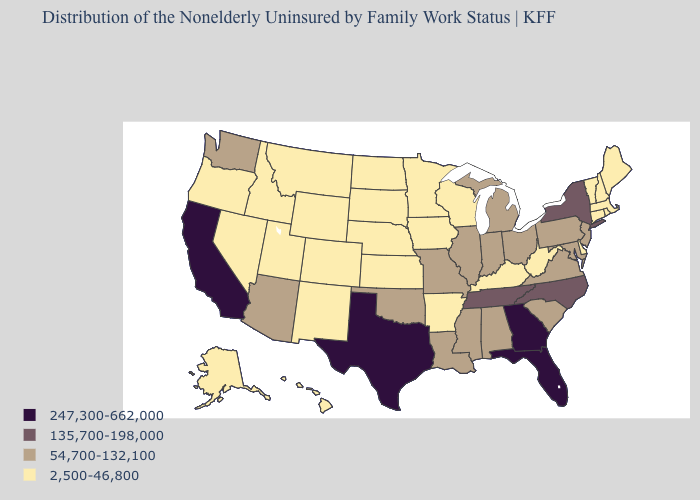What is the lowest value in the USA?
Give a very brief answer. 2,500-46,800. Name the states that have a value in the range 54,700-132,100?
Concise answer only. Alabama, Arizona, Illinois, Indiana, Louisiana, Maryland, Michigan, Mississippi, Missouri, New Jersey, Ohio, Oklahoma, Pennsylvania, South Carolina, Virginia, Washington. Does the first symbol in the legend represent the smallest category?
Keep it brief. No. Which states have the highest value in the USA?
Answer briefly. California, Florida, Georgia, Texas. Does New Mexico have the lowest value in the USA?
Concise answer only. Yes. What is the value of Tennessee?
Quick response, please. 135,700-198,000. What is the value of New Mexico?
Quick response, please. 2,500-46,800. What is the value of Pennsylvania?
Quick response, please. 54,700-132,100. Which states have the lowest value in the Northeast?
Write a very short answer. Connecticut, Maine, Massachusetts, New Hampshire, Rhode Island, Vermont. Does the first symbol in the legend represent the smallest category?
Answer briefly. No. What is the value of Rhode Island?
Answer briefly. 2,500-46,800. Name the states that have a value in the range 135,700-198,000?
Concise answer only. New York, North Carolina, Tennessee. What is the lowest value in the USA?
Short answer required. 2,500-46,800. What is the highest value in the USA?
Quick response, please. 247,300-662,000. How many symbols are there in the legend?
Give a very brief answer. 4. 